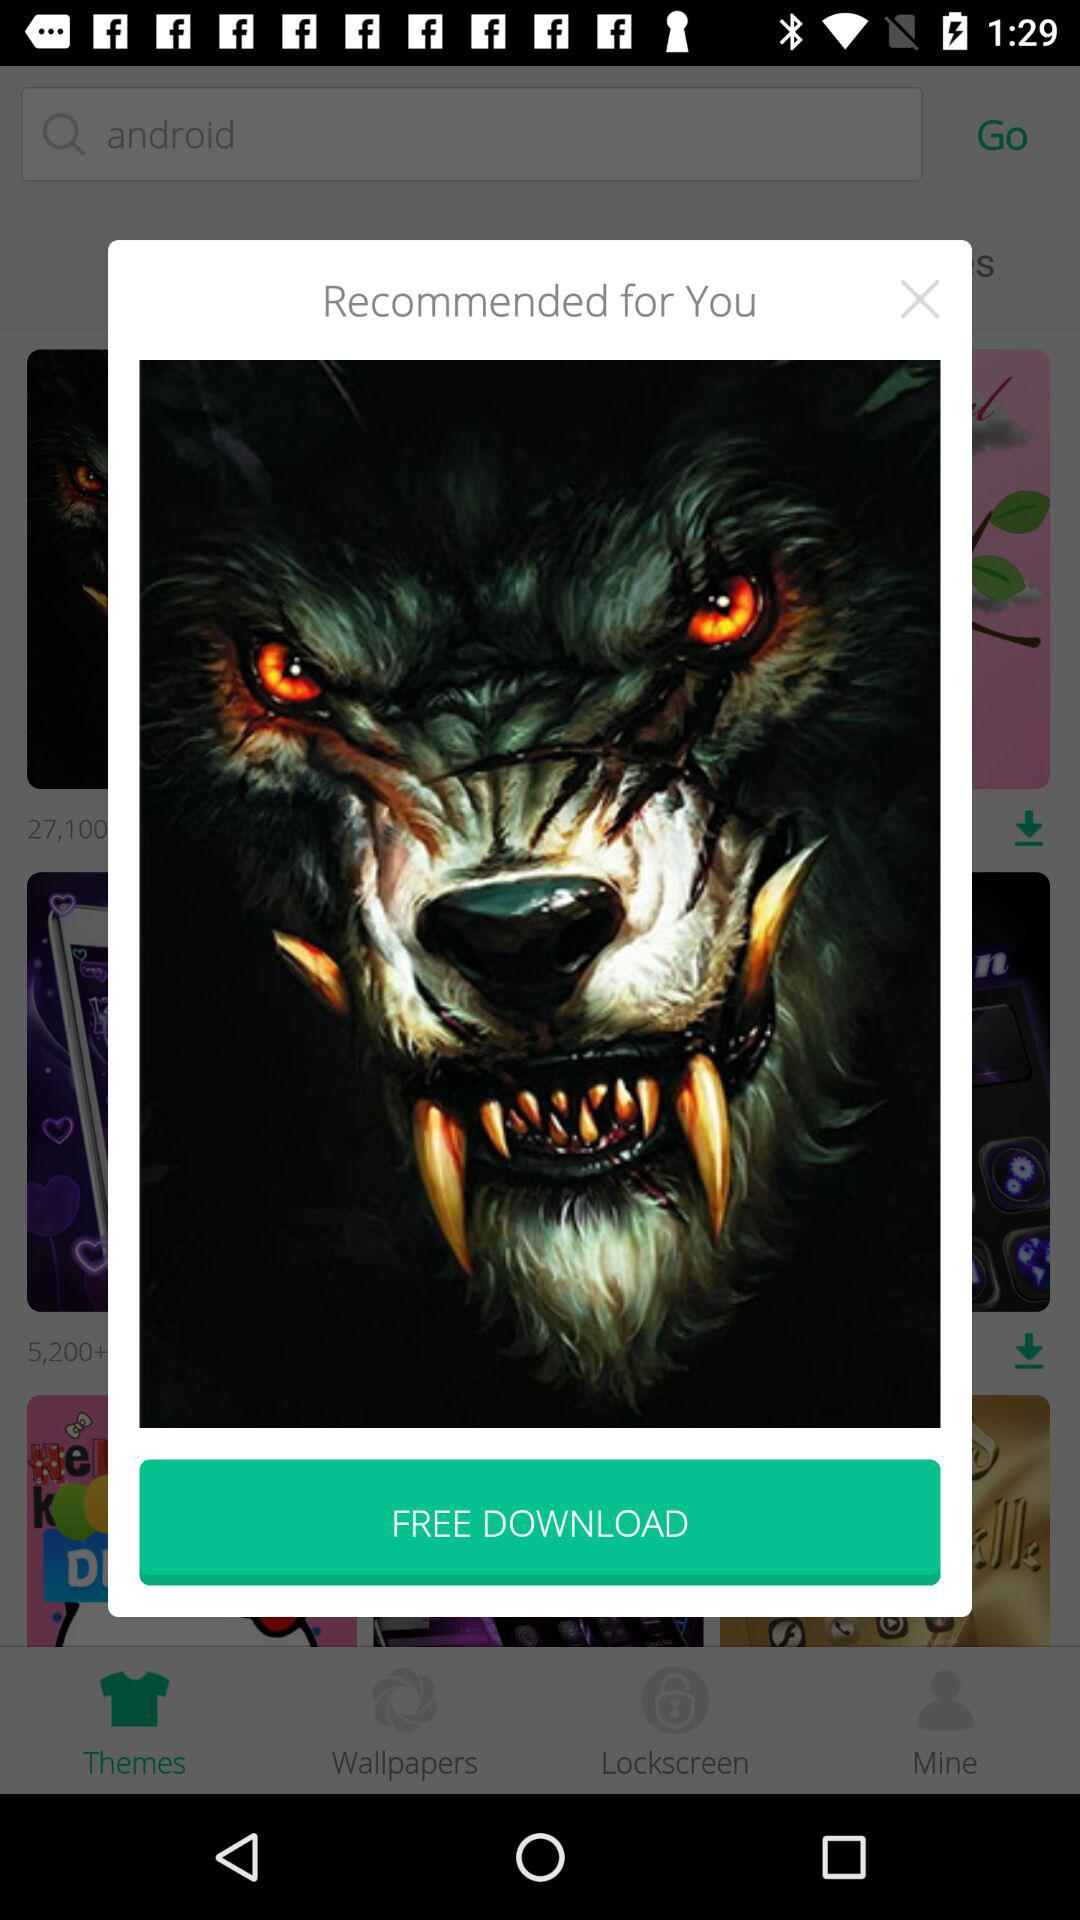Is downloading free or paid?
Answer the question using a single word or phrase. Downloading is free. 